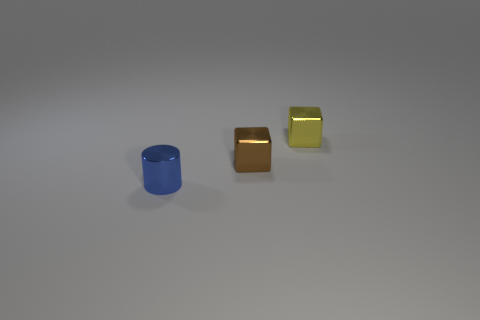Add 3 big blue metal cylinders. How many objects exist? 6 Subtract all cylinders. How many objects are left? 2 Add 3 blue things. How many blue things exist? 4 Subtract 0 purple cylinders. How many objects are left? 3 Subtract all gray rubber cylinders. Subtract all blue things. How many objects are left? 2 Add 3 yellow cubes. How many yellow cubes are left? 4 